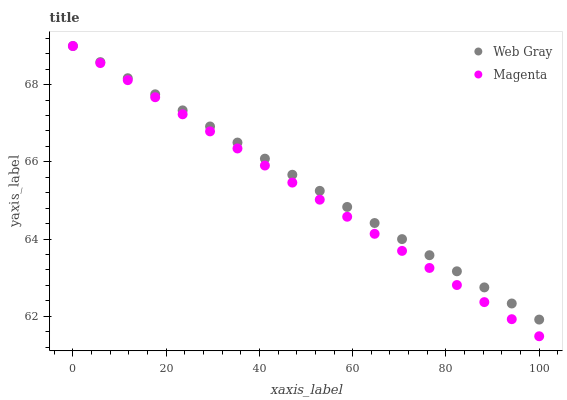Does Magenta have the minimum area under the curve?
Answer yes or no. Yes. Does Web Gray have the maximum area under the curve?
Answer yes or no. Yes. Does Web Gray have the minimum area under the curve?
Answer yes or no. No. Is Web Gray the smoothest?
Answer yes or no. Yes. Is Magenta the roughest?
Answer yes or no. Yes. Is Web Gray the roughest?
Answer yes or no. No. Does Magenta have the lowest value?
Answer yes or no. Yes. Does Web Gray have the lowest value?
Answer yes or no. No. Does Web Gray have the highest value?
Answer yes or no. Yes. Does Web Gray intersect Magenta?
Answer yes or no. Yes. Is Web Gray less than Magenta?
Answer yes or no. No. Is Web Gray greater than Magenta?
Answer yes or no. No. 